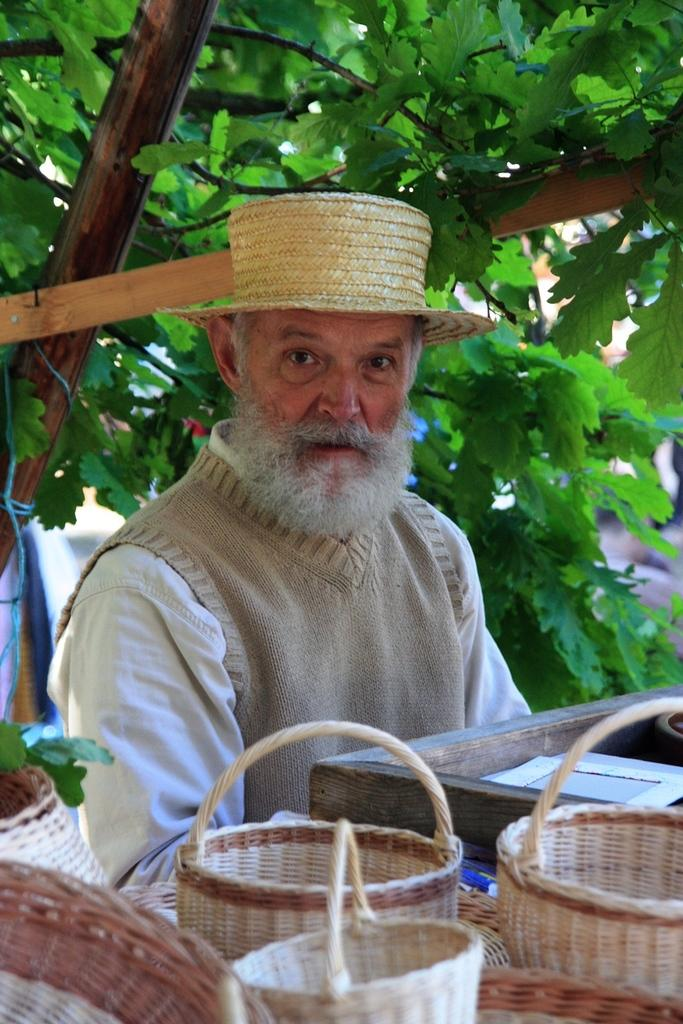What objects are in front of the person in the image? There are baskets in front of the person in the image. What can be seen behind the person in the image? There are leaves visible behind the person in the image. What is the person wearing in the image? The person is wearing clothes and a hat in the image. How does the person demonstrate their beginner status in the image? There is no indication in the image that the person is a beginner at anything. What type of poison is the person handling in the image? There is no poison present in the image; the person is simply wearing a hat and standing near baskets and leaves. 